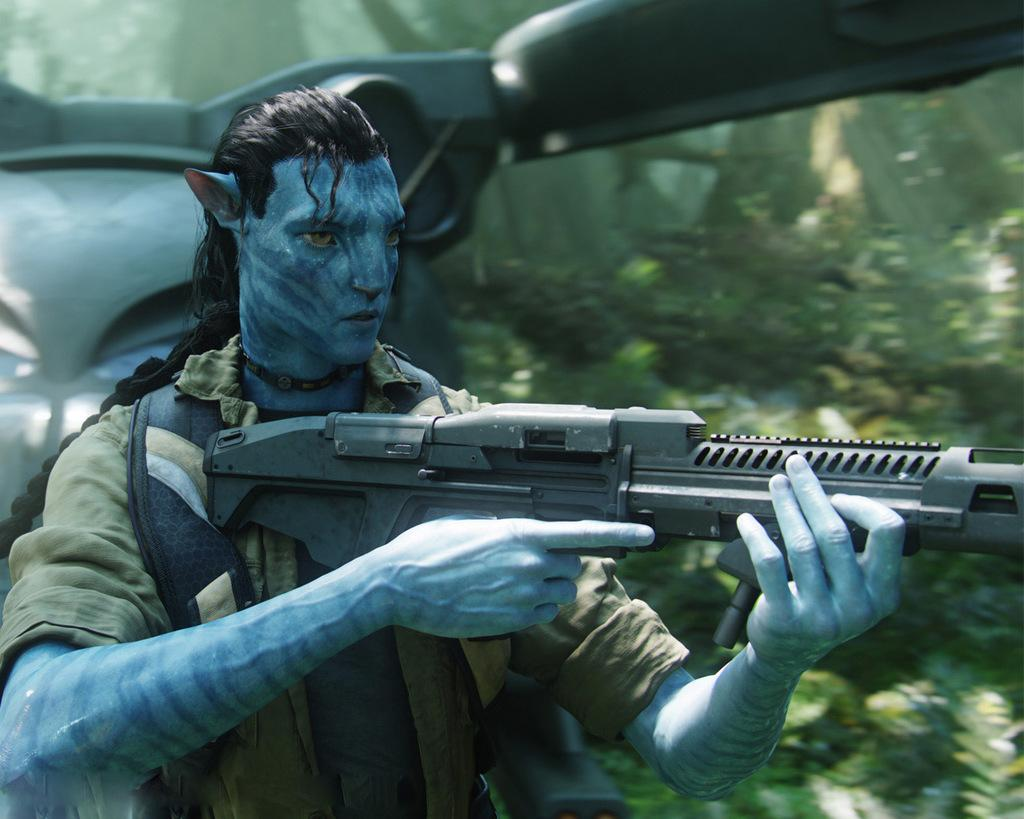What is the main subject of the image? There is a person in the image. What is the person doing in the image? The person is standing in the image. What is the person holding in the image? The person is holding a weapon in the image. What can be seen behind the person in the image? There is a vehicle behind the person in the image. What type of natural scenery is visible in the background of the image? There are trees in the background of the image. What type of bait is the person using to catch fish in the image? There is no indication of fishing or bait in the image; the person is holding a weapon. What type of machine is the person operating in the image? There is no machine present in the image; the person is standing near a vehicle. 